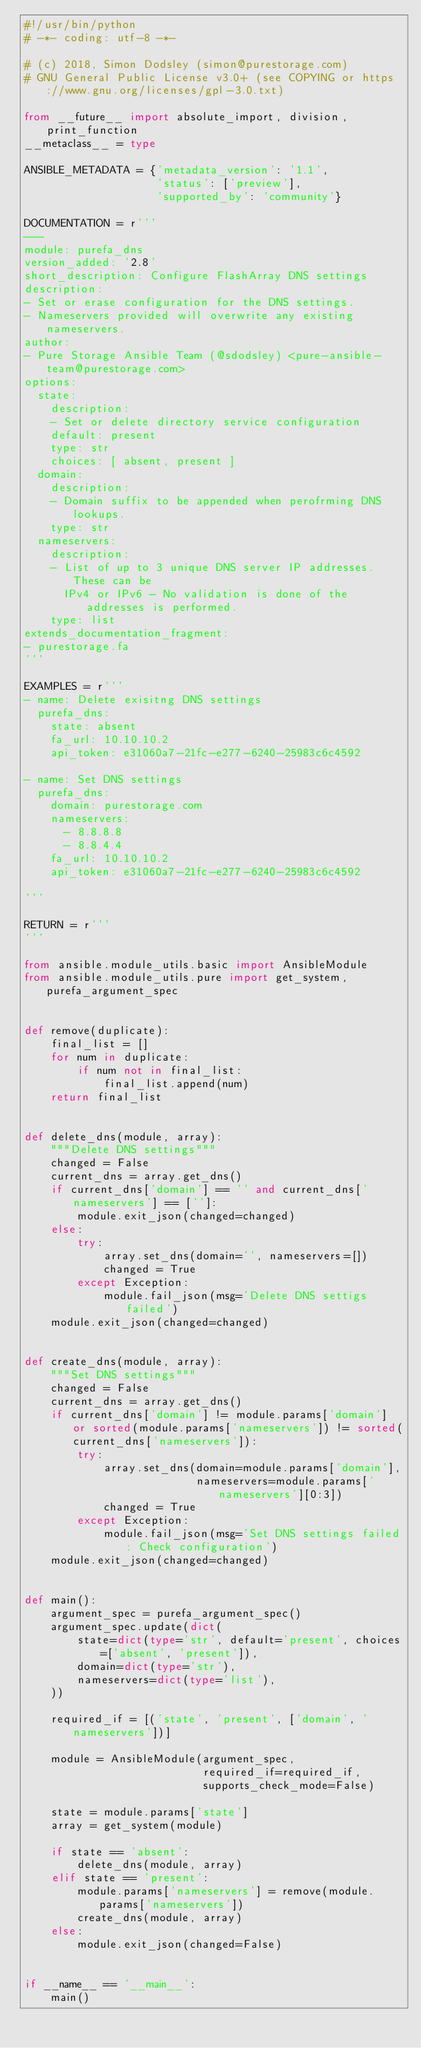Convert code to text. <code><loc_0><loc_0><loc_500><loc_500><_Python_>#!/usr/bin/python
# -*- coding: utf-8 -*-

# (c) 2018, Simon Dodsley (simon@purestorage.com)
# GNU General Public License v3.0+ (see COPYING or https://www.gnu.org/licenses/gpl-3.0.txt)

from __future__ import absolute_import, division, print_function
__metaclass__ = type

ANSIBLE_METADATA = {'metadata_version': '1.1',
                    'status': ['preview'],
                    'supported_by': 'community'}

DOCUMENTATION = r'''
---
module: purefa_dns
version_added: '2.8'
short_description: Configure FlashArray DNS settings
description:
- Set or erase configuration for the DNS settings.
- Nameservers provided will overwrite any existing nameservers.
author:
- Pure Storage Ansible Team (@sdodsley) <pure-ansible-team@purestorage.com>
options:
  state:
    description:
    - Set or delete directory service configuration
    default: present
    type: str
    choices: [ absent, present ]
  domain:
    description:
    - Domain suffix to be appended when perofrming DNS lookups.
    type: str
  nameservers:
    description:
    - List of up to 3 unique DNS server IP addresses. These can be
      IPv4 or IPv6 - No validation is done of the addresses is performed.
    type: list
extends_documentation_fragment:
- purestorage.fa
'''

EXAMPLES = r'''
- name: Delete exisitng DNS settings
  purefa_dns:
    state: absent
    fa_url: 10.10.10.2
    api_token: e31060a7-21fc-e277-6240-25983c6c4592

- name: Set DNS settings
  purefa_dns:
    domain: purestorage.com
    nameservers:
      - 8.8.8.8
      - 8.8.4.4
    fa_url: 10.10.10.2
    api_token: e31060a7-21fc-e277-6240-25983c6c4592

'''

RETURN = r'''
'''

from ansible.module_utils.basic import AnsibleModule
from ansible.module_utils.pure import get_system, purefa_argument_spec


def remove(duplicate):
    final_list = []
    for num in duplicate:
        if num not in final_list:
            final_list.append(num)
    return final_list


def delete_dns(module, array):
    """Delete DNS settings"""
    changed = False
    current_dns = array.get_dns()
    if current_dns['domain'] == '' and current_dns['nameservers'] == ['']:
        module.exit_json(changed=changed)
    else:
        try:
            array.set_dns(domain='', nameservers=[])
            changed = True
        except Exception:
            module.fail_json(msg='Delete DNS settigs failed')
    module.exit_json(changed=changed)


def create_dns(module, array):
    """Set DNS settings"""
    changed = False
    current_dns = array.get_dns()
    if current_dns['domain'] != module.params['domain'] or sorted(module.params['nameservers']) != sorted(current_dns['nameservers']):
        try:
            array.set_dns(domain=module.params['domain'],
                          nameservers=module.params['nameservers'][0:3])
            changed = True
        except Exception:
            module.fail_json(msg='Set DNS settings failed: Check configuration')
    module.exit_json(changed=changed)


def main():
    argument_spec = purefa_argument_spec()
    argument_spec.update(dict(
        state=dict(type='str', default='present', choices=['absent', 'present']),
        domain=dict(type='str'),
        nameservers=dict(type='list'),
    ))

    required_if = [('state', 'present', ['domain', 'nameservers'])]

    module = AnsibleModule(argument_spec,
                           required_if=required_if,
                           supports_check_mode=False)

    state = module.params['state']
    array = get_system(module)

    if state == 'absent':
        delete_dns(module, array)
    elif state == 'present':
        module.params['nameservers'] = remove(module.params['nameservers'])
        create_dns(module, array)
    else:
        module.exit_json(changed=False)


if __name__ == '__main__':
    main()
</code> 